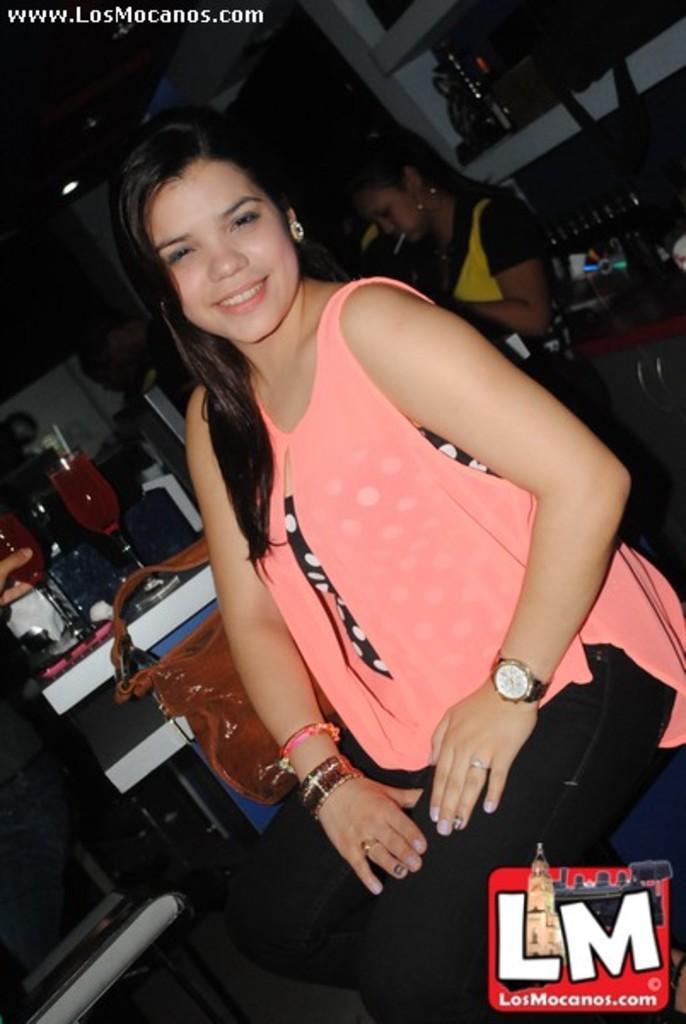Please provide a concise description of this image. In this picture I can see a woman smiling and sitting on the chair. I can see wine glasses and some other objects on the table and on the cabinet, and in the background there are few people and there are watermarks on the image. 